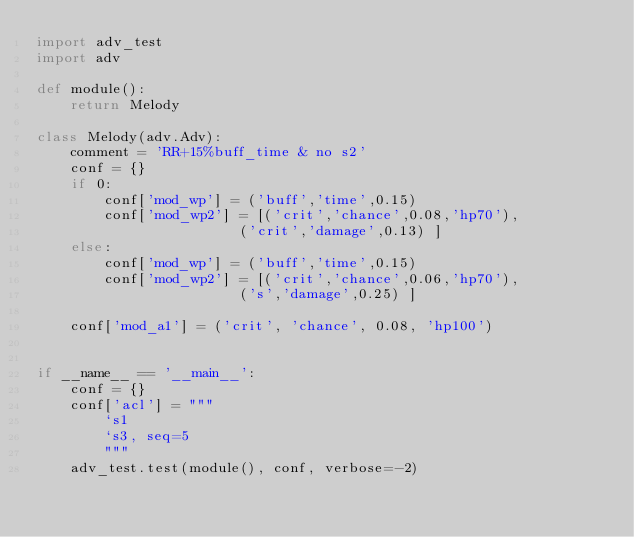<code> <loc_0><loc_0><loc_500><loc_500><_Python_>import adv_test
import adv

def module():
    return Melody

class Melody(adv.Adv):
    comment = 'RR+15%buff_time & no s2'
    conf = {}
    if 0:
        conf['mod_wp'] = ('buff','time',0.15)
        conf['mod_wp2'] = [('crit','chance',0.08,'hp70'),
                        ('crit','damage',0.13) ]
    else:
        conf['mod_wp'] = ('buff','time',0.15)
        conf['mod_wp2'] = [('crit','chance',0.06,'hp70'),
                        ('s','damage',0.25) ]

    conf['mod_a1'] = ('crit', 'chance', 0.08, 'hp100')


if __name__ == '__main__':
    conf = {}
    conf['acl'] = """
        `s1
        `s3, seq=5
        """
    adv_test.test(module(), conf, verbose=-2)

</code> 